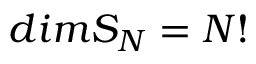Convert formula to latex. <formula><loc_0><loc_0><loc_500><loc_500>d i m S _ { N } = N !</formula> 